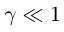<formula> <loc_0><loc_0><loc_500><loc_500>\gamma \ll 1</formula> 